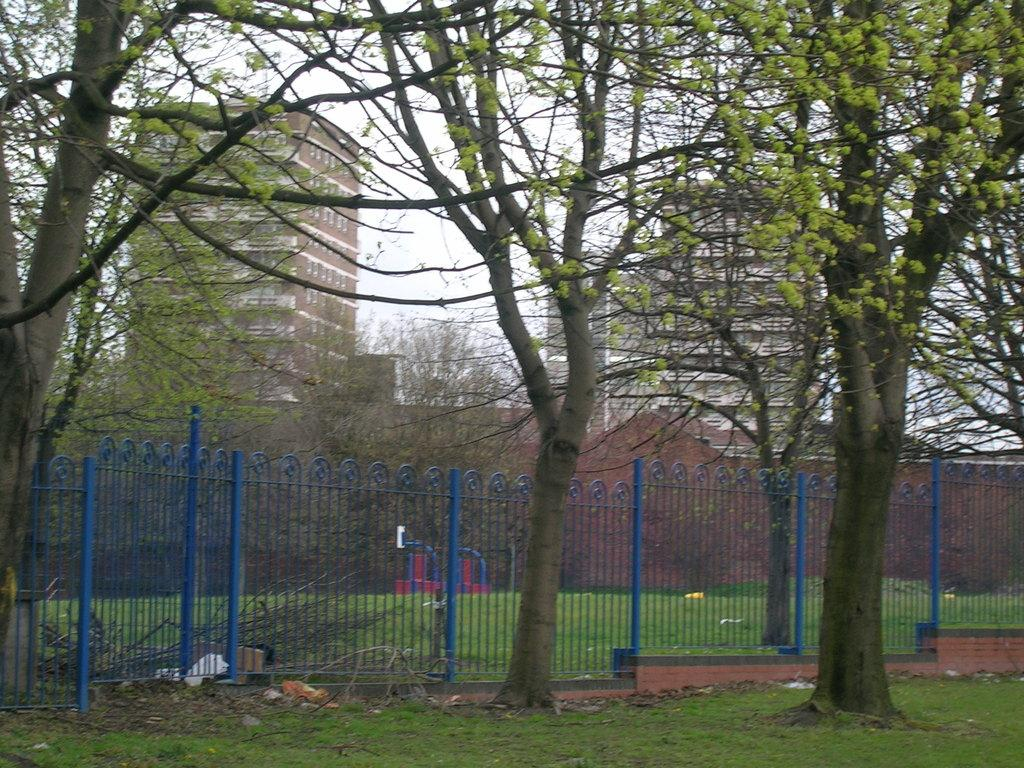What type of natural elements can be seen in the image? There are many trees in the image. What type of structure can be seen in the image? There is a railing in the image. What type of man-made structures can be seen in the image? There are buildings in the image. What is visible in the background of the image? The sky is visible in the background of the image. Where is the crate located in the image? There is no crate present in the image. What type of map can be seen in the image? There is no map present in the image. 